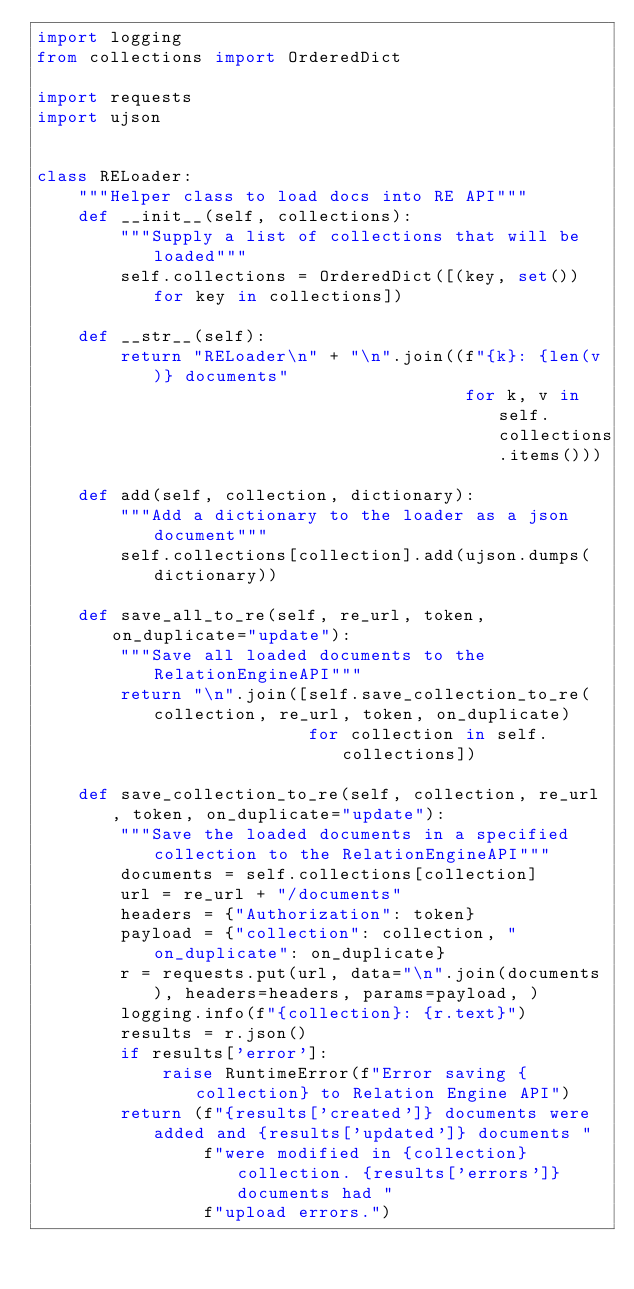Convert code to text. <code><loc_0><loc_0><loc_500><loc_500><_Python_>import logging
from collections import OrderedDict

import requests
import ujson


class RELoader:
    """Helper class to load docs into RE API"""
    def __init__(self, collections):
        """Supply a list of collections that will be loaded"""
        self.collections = OrderedDict([(key, set()) for key in collections])

    def __str__(self):
        return "RELoader\n" + "\n".join((f"{k}: {len(v)} documents"
                                         for k, v in self.collections.items()))

    def add(self, collection, dictionary):
        """Add a dictionary to the loader as a json document"""
        self.collections[collection].add(ujson.dumps(dictionary))

    def save_all_to_re(self, re_url, token, on_duplicate="update"):
        """Save all loaded documents to the RelationEngineAPI"""
        return "\n".join([self.save_collection_to_re(collection, re_url, token, on_duplicate)
                          for collection in self.collections])

    def save_collection_to_re(self, collection, re_url, token, on_duplicate="update"):
        """Save the loaded documents in a specified collection to the RelationEngineAPI"""
        documents = self.collections[collection]
        url = re_url + "/documents"
        headers = {"Authorization": token}
        payload = {"collection": collection, "on_duplicate": on_duplicate}
        r = requests.put(url, data="\n".join(documents), headers=headers, params=payload, )
        logging.info(f"{collection}: {r.text}")
        results = r.json()
        if results['error']:
            raise RuntimeError(f"Error saving {collection} to Relation Engine API")
        return (f"{results['created']} documents were added and {results['updated']} documents "
                f"were modified in {collection} collection. {results['errors']} documents had "
                f"upload errors.")


</code> 